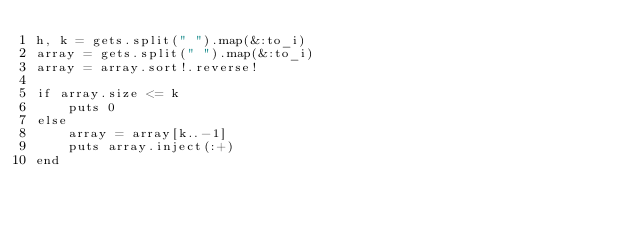<code> <loc_0><loc_0><loc_500><loc_500><_Ruby_>h, k = gets.split(" ").map(&:to_i)
array = gets.split(" ").map(&:to_i)
array = array.sort!.reverse!

if array.size <= k
    puts 0
else
    array = array[k..-1]
    puts array.inject(:+)
end
</code> 